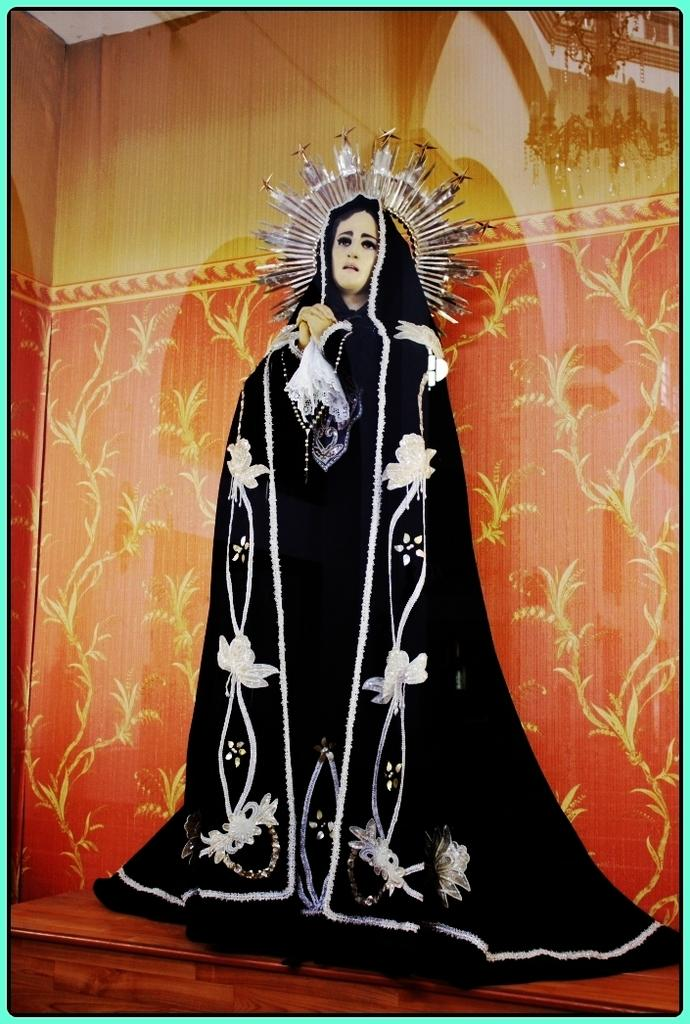What is the main subject in the center of the image? There is a statue in the center of the image. What can be seen in the background of the image? There is a wall in the background of the image. How many chairs are placed around the statue in the image? There are no chairs visible in the image; it only features a statue and a wall in the background. 